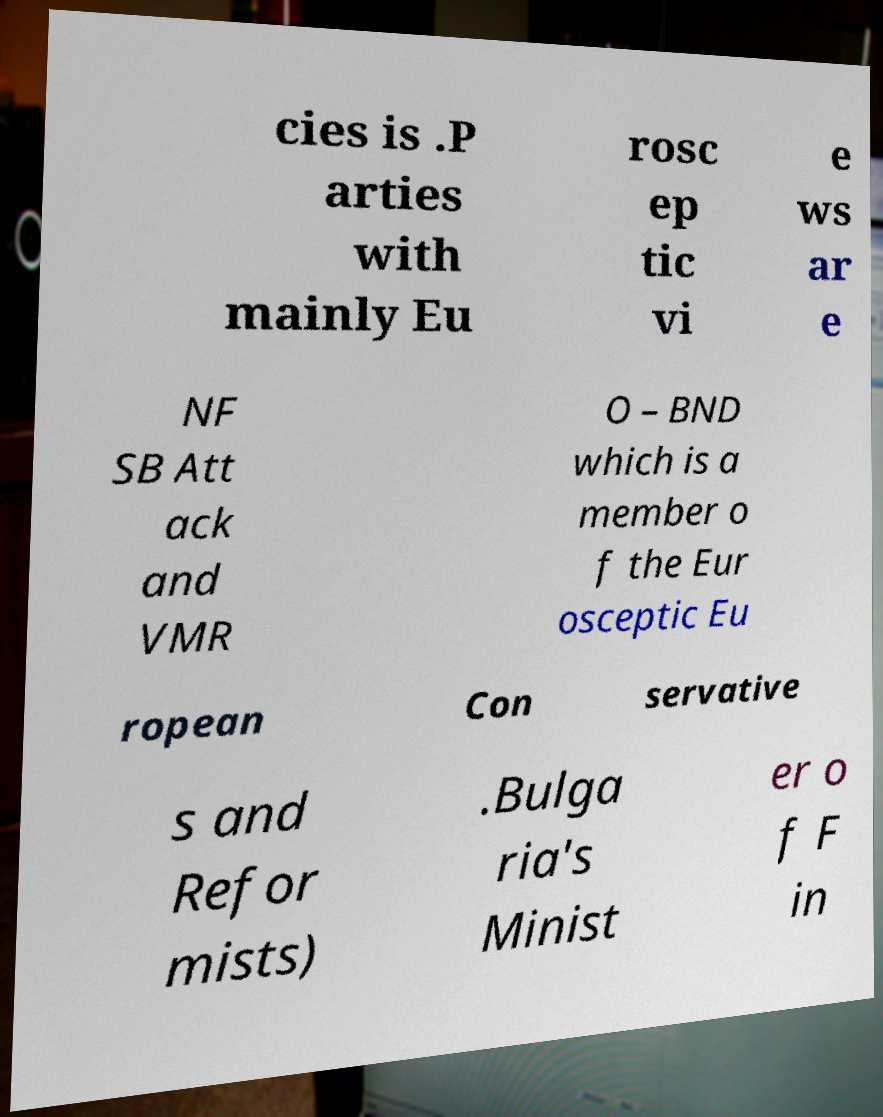Can you accurately transcribe the text from the provided image for me? cies is .P arties with mainly Eu rosc ep tic vi e ws ar e NF SB Att ack and VMR O – BND which is a member o f the Eur osceptic Eu ropean Con servative s and Refor mists) .Bulga ria's Minist er o f F in 